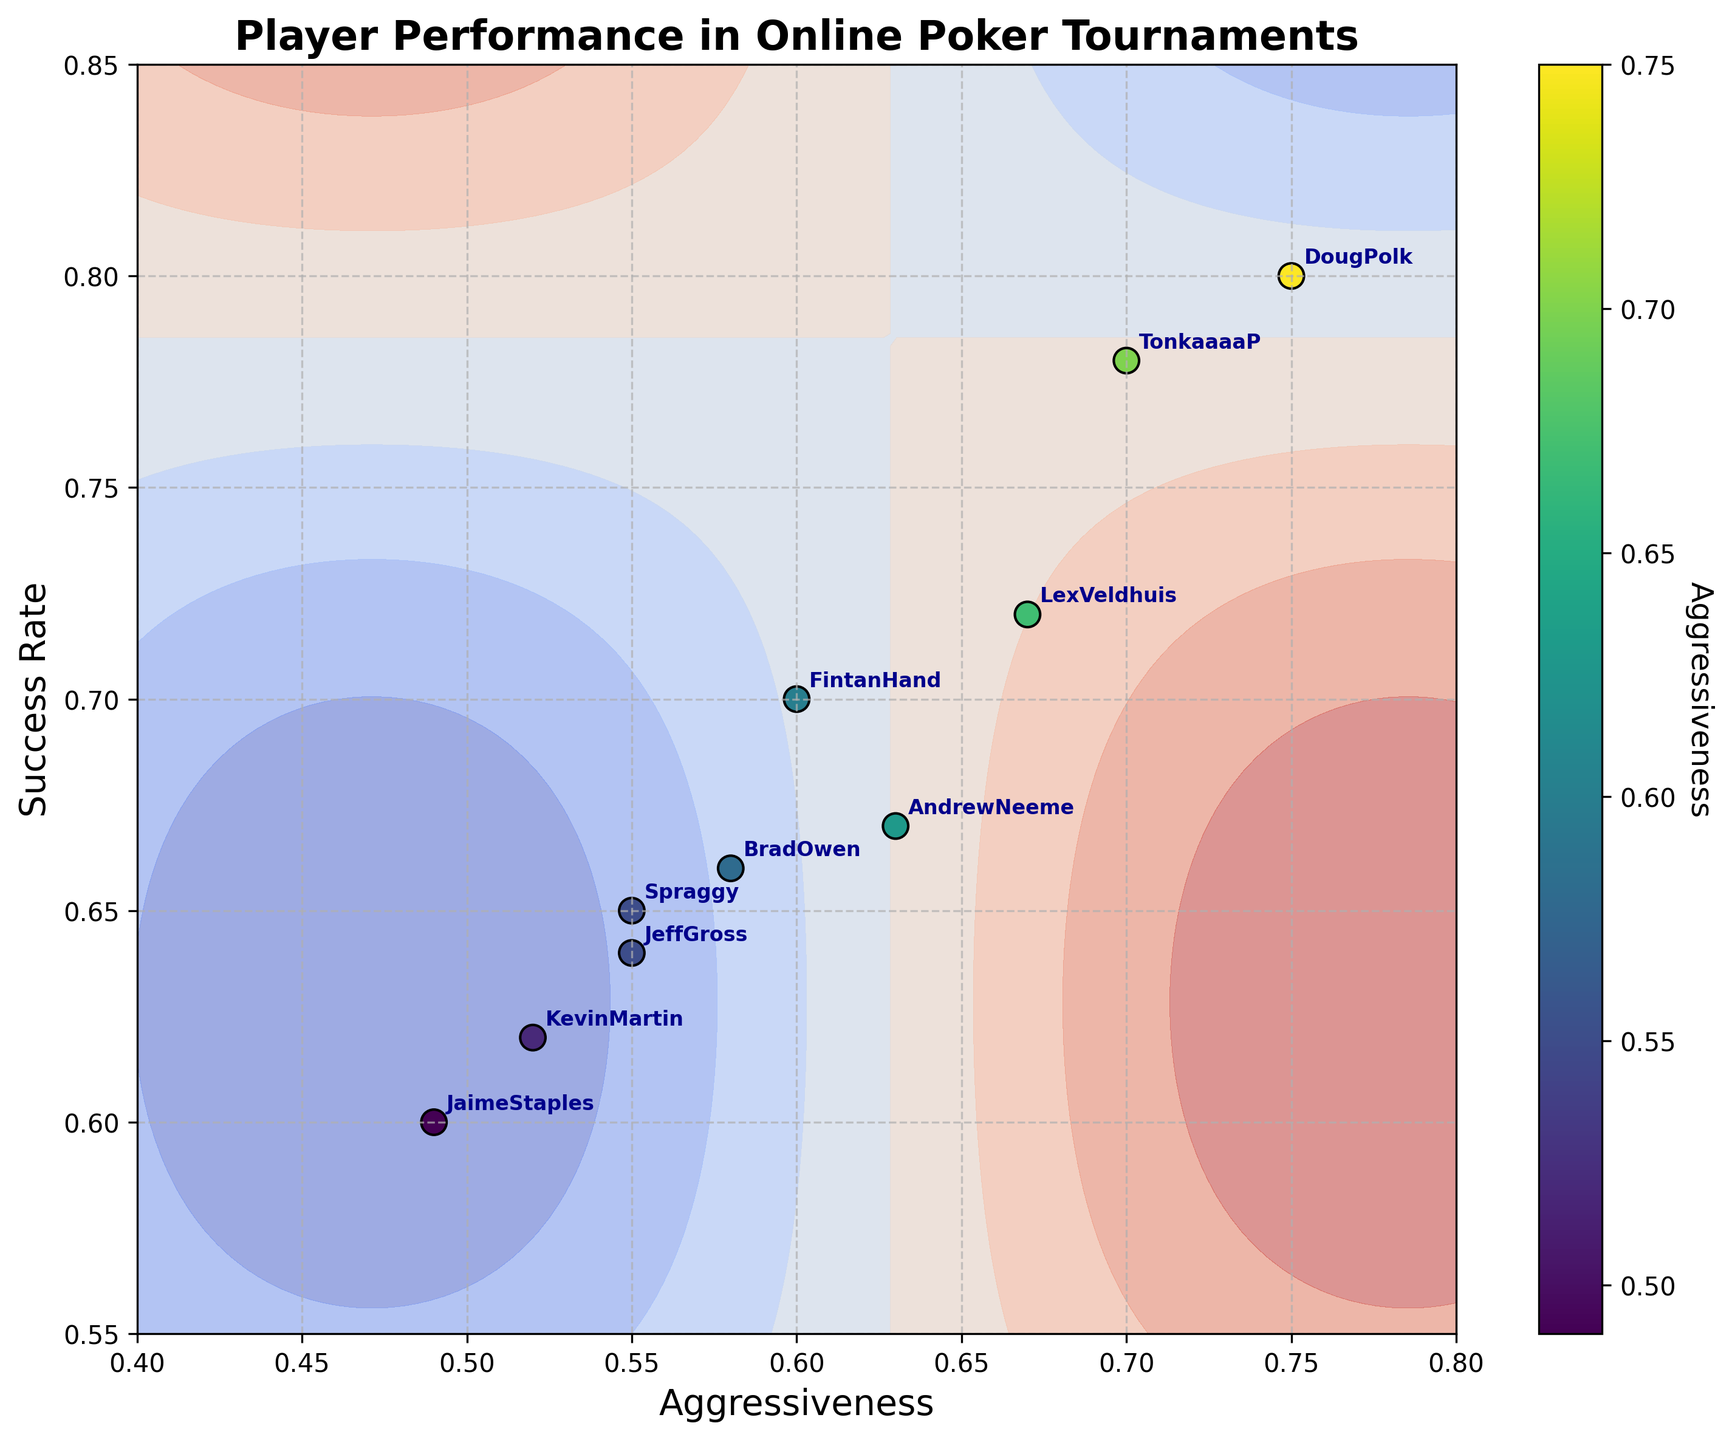how many players are shown in the figure? The figure includes data points for each player. By counting the labeled points, we can determine the number of players displayed.
Answer: 10 what is the title of the figure? The title is displayed at the top of the figure, providing context about what the figure shows.
Answer: "Player Performance in Online Poker Tournaments" which player has the highest success rate? Identifying the highest point along the vertical axis (Success Rate) corresponds to finding the player with the highest success rate.
Answer: DougPolk what is the aggressiveness and success rate of LexVeldhuis? Locate the labeled point for LexVeldhuis and read the x (Aggressiveness) and y (Success Rate) values directly.
Answer: 0.67 and 0.72 how many players have an aggressiveness score greater than 0.60? Count the labeled points where the x-axis value (Aggressiveness) is greater than 0.60.
Answer: 5 what is the average success rate of players attending the SundayMillion tournament? Find the points corresponding to SundayMillion, sum the y values (Success Rate) of those points, and divide by the number of points. (0.72 + 0.67)/2 = 0.695
Answer: 0.695 who is more aggressive, TonkaaaaP or Spraggy? Compare the x-axis values (Aggressiveness) for TonkaaaaP and Spraggy. The one with the higher value is more aggressive.
Answer: TonkaaaaP which tournaments are represented in the figure? By looking at the player labels and additional context such as colors and annotations, we can list out the unique tournament names.
Answer: SundayMillion, Big109, Powerfest, SCOOP, WinterSeries, HighRoller is there a correlation between aggressiveness and success rate in this figure? Observe whether there is a noticeable trend or pattern in the distribution of points that indicates a relationship between aggressiveness (x-axis) and success rate (y-axis).
Answer: Yes which player has the closest combination of aggressiveness and success rate to the values 0.60 and 0.70? Compare the coordinates of each point to (0.60, 0.70) and find the one with the closest values.
Answer: FintanHand 